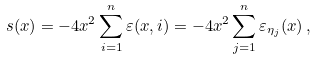Convert formula to latex. <formula><loc_0><loc_0><loc_500><loc_500>s ( x ) = - 4 x ^ { 2 } \sum _ { i = 1 } ^ { n } \varepsilon ( x , i ) = - 4 x ^ { 2 } \sum _ { j = 1 } ^ { n } \varepsilon _ { \eta _ { j } } ( x ) \, ,</formula> 